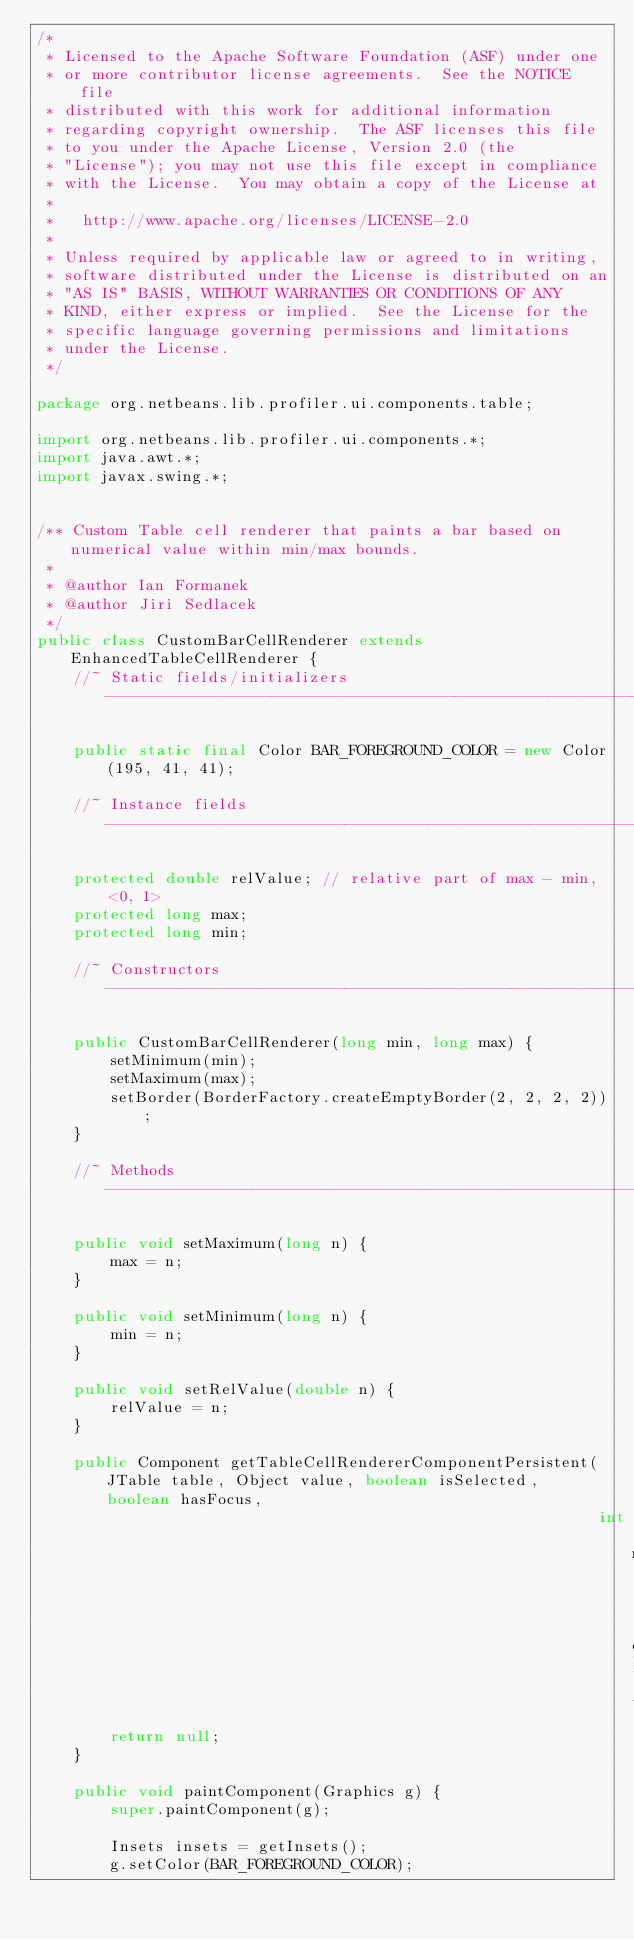Convert code to text. <code><loc_0><loc_0><loc_500><loc_500><_Java_>/*
 * Licensed to the Apache Software Foundation (ASF) under one
 * or more contributor license agreements.  See the NOTICE file
 * distributed with this work for additional information
 * regarding copyright ownership.  The ASF licenses this file
 * to you under the Apache License, Version 2.0 (the
 * "License"); you may not use this file except in compliance
 * with the License.  You may obtain a copy of the License at
 *
 *   http://www.apache.org/licenses/LICENSE-2.0
 *
 * Unless required by applicable law or agreed to in writing,
 * software distributed under the License is distributed on an
 * "AS IS" BASIS, WITHOUT WARRANTIES OR CONDITIONS OF ANY
 * KIND, either express or implied.  See the License for the
 * specific language governing permissions and limitations
 * under the License.
 */

package org.netbeans.lib.profiler.ui.components.table;

import org.netbeans.lib.profiler.ui.components.*;
import java.awt.*;
import javax.swing.*;


/** Custom Table cell renderer that paints a bar based on numerical value within min/max bounds.
 *
 * @author Ian Formanek
 * @author Jiri Sedlacek
 */
public class CustomBarCellRenderer extends EnhancedTableCellRenderer {
    //~ Static fields/initializers -----------------------------------------------------------------------------------------------

    public static final Color BAR_FOREGROUND_COLOR = new Color(195, 41, 41);

    //~ Instance fields ----------------------------------------------------------------------------------------------------------

    protected double relValue; // relative part of max - min, <0, 1>
    protected long max;
    protected long min;

    //~ Constructors -------------------------------------------------------------------------------------------------------------

    public CustomBarCellRenderer(long min, long max) {
        setMinimum(min);
        setMaximum(max);
        setBorder(BorderFactory.createEmptyBorder(2, 2, 2, 2));
    }

    //~ Methods ------------------------------------------------------------------------------------------------------------------

    public void setMaximum(long n) {
        max = n;
    }

    public void setMinimum(long n) {
        min = n;
    }

    public void setRelValue(double n) {
        relValue = n;
    }

    public Component getTableCellRendererComponentPersistent(JTable table, Object value, boolean isSelected, boolean hasFocus,
                                                             int row, int column) {
        return null;
    }

    public void paintComponent(Graphics g) {
        super.paintComponent(g);

        Insets insets = getInsets();
        g.setColor(BAR_FOREGROUND_COLOR);</code> 